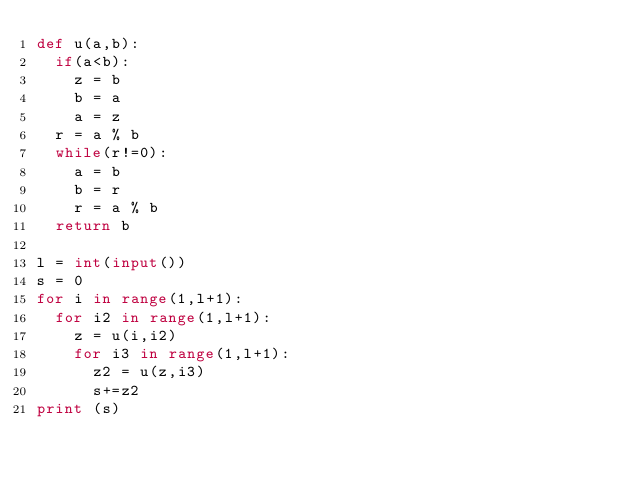Convert code to text. <code><loc_0><loc_0><loc_500><loc_500><_Python_>def u(a,b):
  if(a<b):
    z = b
    b = a
    a = z
  r = a % b
  while(r!=0):
    a = b
    b = r
    r = a % b
  return b
 
l = int(input())
s = 0
for i in range(1,l+1):
  for i2 in range(1,l+1):
    z = u(i,i2)
    for i3 in range(1,l+1):
      z2 = u(z,i3)
      s+=z2
print (s)</code> 